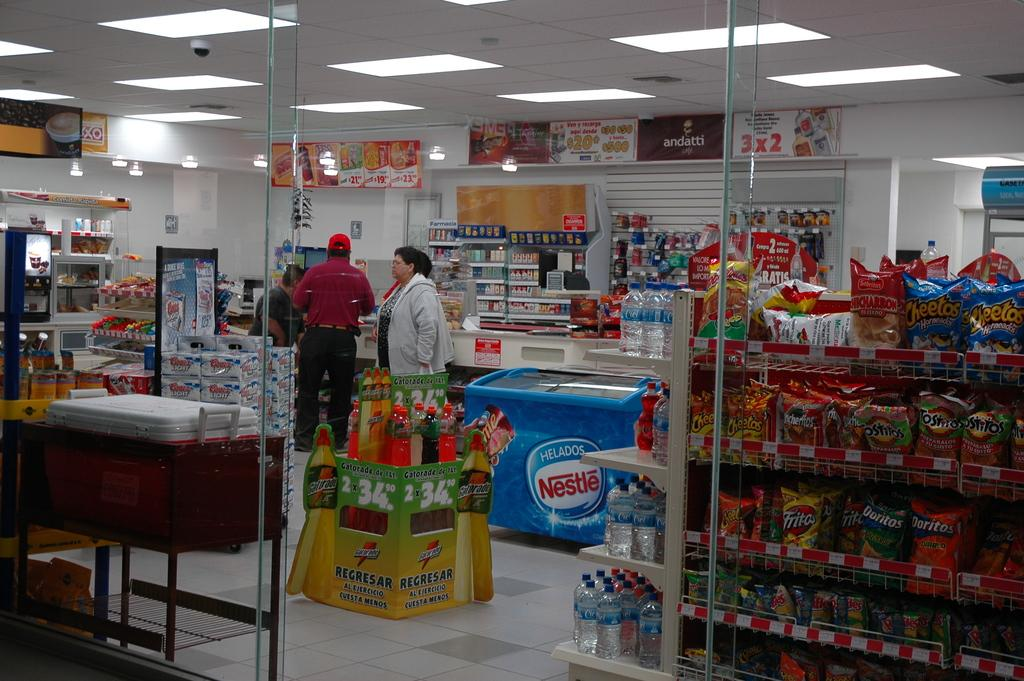Provide a one-sentence caption for the provided image. A store that is selling Gatorade from a green box. 